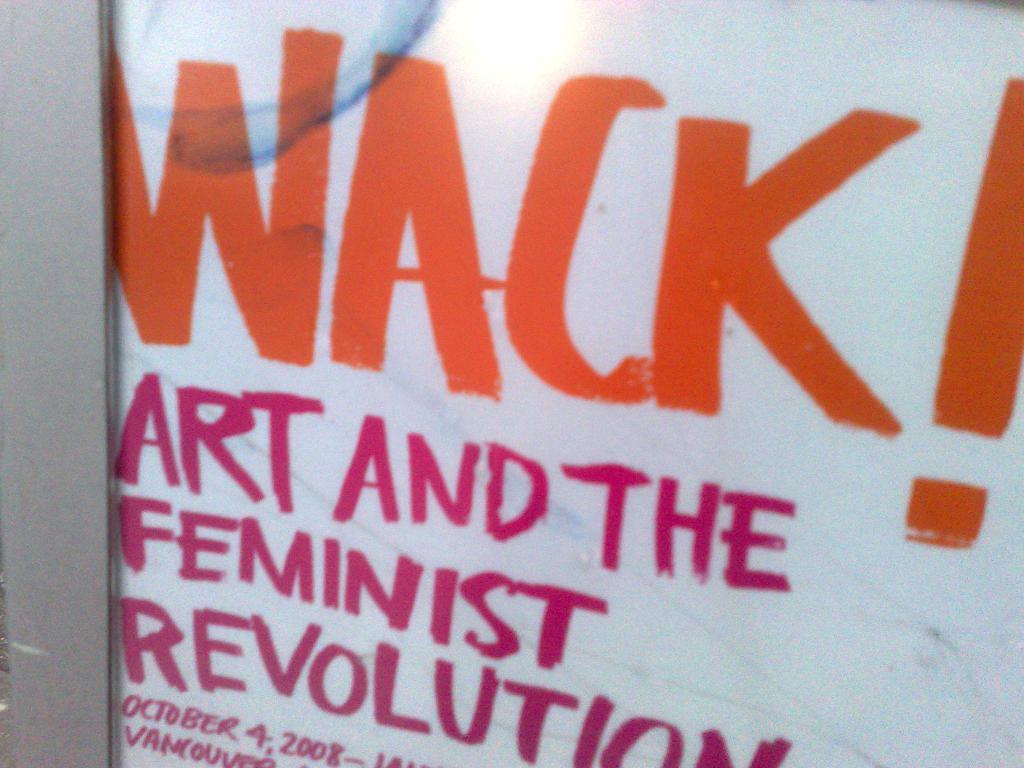What is feminist revolution?
Make the answer very short. Wack!. What is this event called?
Provide a succinct answer. Wack!. 